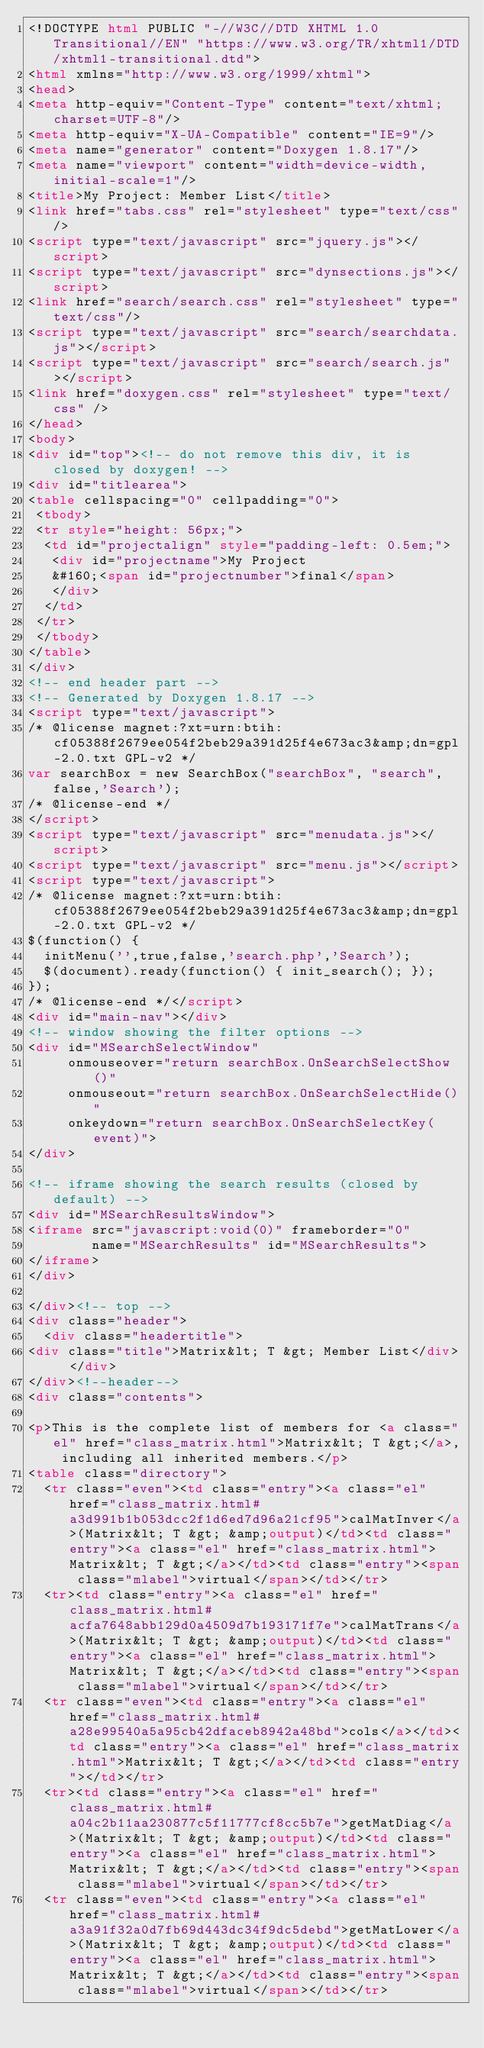<code> <loc_0><loc_0><loc_500><loc_500><_HTML_><!DOCTYPE html PUBLIC "-//W3C//DTD XHTML 1.0 Transitional//EN" "https://www.w3.org/TR/xhtml1/DTD/xhtml1-transitional.dtd">
<html xmlns="http://www.w3.org/1999/xhtml">
<head>
<meta http-equiv="Content-Type" content="text/xhtml;charset=UTF-8"/>
<meta http-equiv="X-UA-Compatible" content="IE=9"/>
<meta name="generator" content="Doxygen 1.8.17"/>
<meta name="viewport" content="width=device-width, initial-scale=1"/>
<title>My Project: Member List</title>
<link href="tabs.css" rel="stylesheet" type="text/css"/>
<script type="text/javascript" src="jquery.js"></script>
<script type="text/javascript" src="dynsections.js"></script>
<link href="search/search.css" rel="stylesheet" type="text/css"/>
<script type="text/javascript" src="search/searchdata.js"></script>
<script type="text/javascript" src="search/search.js"></script>
<link href="doxygen.css" rel="stylesheet" type="text/css" />
</head>
<body>
<div id="top"><!-- do not remove this div, it is closed by doxygen! -->
<div id="titlearea">
<table cellspacing="0" cellpadding="0">
 <tbody>
 <tr style="height: 56px;">
  <td id="projectalign" style="padding-left: 0.5em;">
   <div id="projectname">My Project
   &#160;<span id="projectnumber">final</span>
   </div>
  </td>
 </tr>
 </tbody>
</table>
</div>
<!-- end header part -->
<!-- Generated by Doxygen 1.8.17 -->
<script type="text/javascript">
/* @license magnet:?xt=urn:btih:cf05388f2679ee054f2beb29a391d25f4e673ac3&amp;dn=gpl-2.0.txt GPL-v2 */
var searchBox = new SearchBox("searchBox", "search",false,'Search');
/* @license-end */
</script>
<script type="text/javascript" src="menudata.js"></script>
<script type="text/javascript" src="menu.js"></script>
<script type="text/javascript">
/* @license magnet:?xt=urn:btih:cf05388f2679ee054f2beb29a391d25f4e673ac3&amp;dn=gpl-2.0.txt GPL-v2 */
$(function() {
  initMenu('',true,false,'search.php','Search');
  $(document).ready(function() { init_search(); });
});
/* @license-end */</script>
<div id="main-nav"></div>
<!-- window showing the filter options -->
<div id="MSearchSelectWindow"
     onmouseover="return searchBox.OnSearchSelectShow()"
     onmouseout="return searchBox.OnSearchSelectHide()"
     onkeydown="return searchBox.OnSearchSelectKey(event)">
</div>

<!-- iframe showing the search results (closed by default) -->
<div id="MSearchResultsWindow">
<iframe src="javascript:void(0)" frameborder="0" 
        name="MSearchResults" id="MSearchResults">
</iframe>
</div>

</div><!-- top -->
<div class="header">
  <div class="headertitle">
<div class="title">Matrix&lt; T &gt; Member List</div>  </div>
</div><!--header-->
<div class="contents">

<p>This is the complete list of members for <a class="el" href="class_matrix.html">Matrix&lt; T &gt;</a>, including all inherited members.</p>
<table class="directory">
  <tr class="even"><td class="entry"><a class="el" href="class_matrix.html#a3d991b1b053dcc2f1d6ed7d96a21cf95">calMatInver</a>(Matrix&lt; T &gt; &amp;output)</td><td class="entry"><a class="el" href="class_matrix.html">Matrix&lt; T &gt;</a></td><td class="entry"><span class="mlabel">virtual</span></td></tr>
  <tr><td class="entry"><a class="el" href="class_matrix.html#acfa7648abb129d0a4509d7b193171f7e">calMatTrans</a>(Matrix&lt; T &gt; &amp;output)</td><td class="entry"><a class="el" href="class_matrix.html">Matrix&lt; T &gt;</a></td><td class="entry"><span class="mlabel">virtual</span></td></tr>
  <tr class="even"><td class="entry"><a class="el" href="class_matrix.html#a28e99540a5a95cb42dfaceb8942a48bd">cols</a></td><td class="entry"><a class="el" href="class_matrix.html">Matrix&lt; T &gt;</a></td><td class="entry"></td></tr>
  <tr><td class="entry"><a class="el" href="class_matrix.html#a04c2b11aa230877c5f11777cf8cc5b7e">getMatDiag</a>(Matrix&lt; T &gt; &amp;output)</td><td class="entry"><a class="el" href="class_matrix.html">Matrix&lt; T &gt;</a></td><td class="entry"><span class="mlabel">virtual</span></td></tr>
  <tr class="even"><td class="entry"><a class="el" href="class_matrix.html#a3a91f32a0d7fb69d443dc34f9dc5debd">getMatLower</a>(Matrix&lt; T &gt; &amp;output)</td><td class="entry"><a class="el" href="class_matrix.html">Matrix&lt; T &gt;</a></td><td class="entry"><span class="mlabel">virtual</span></td></tr></code> 